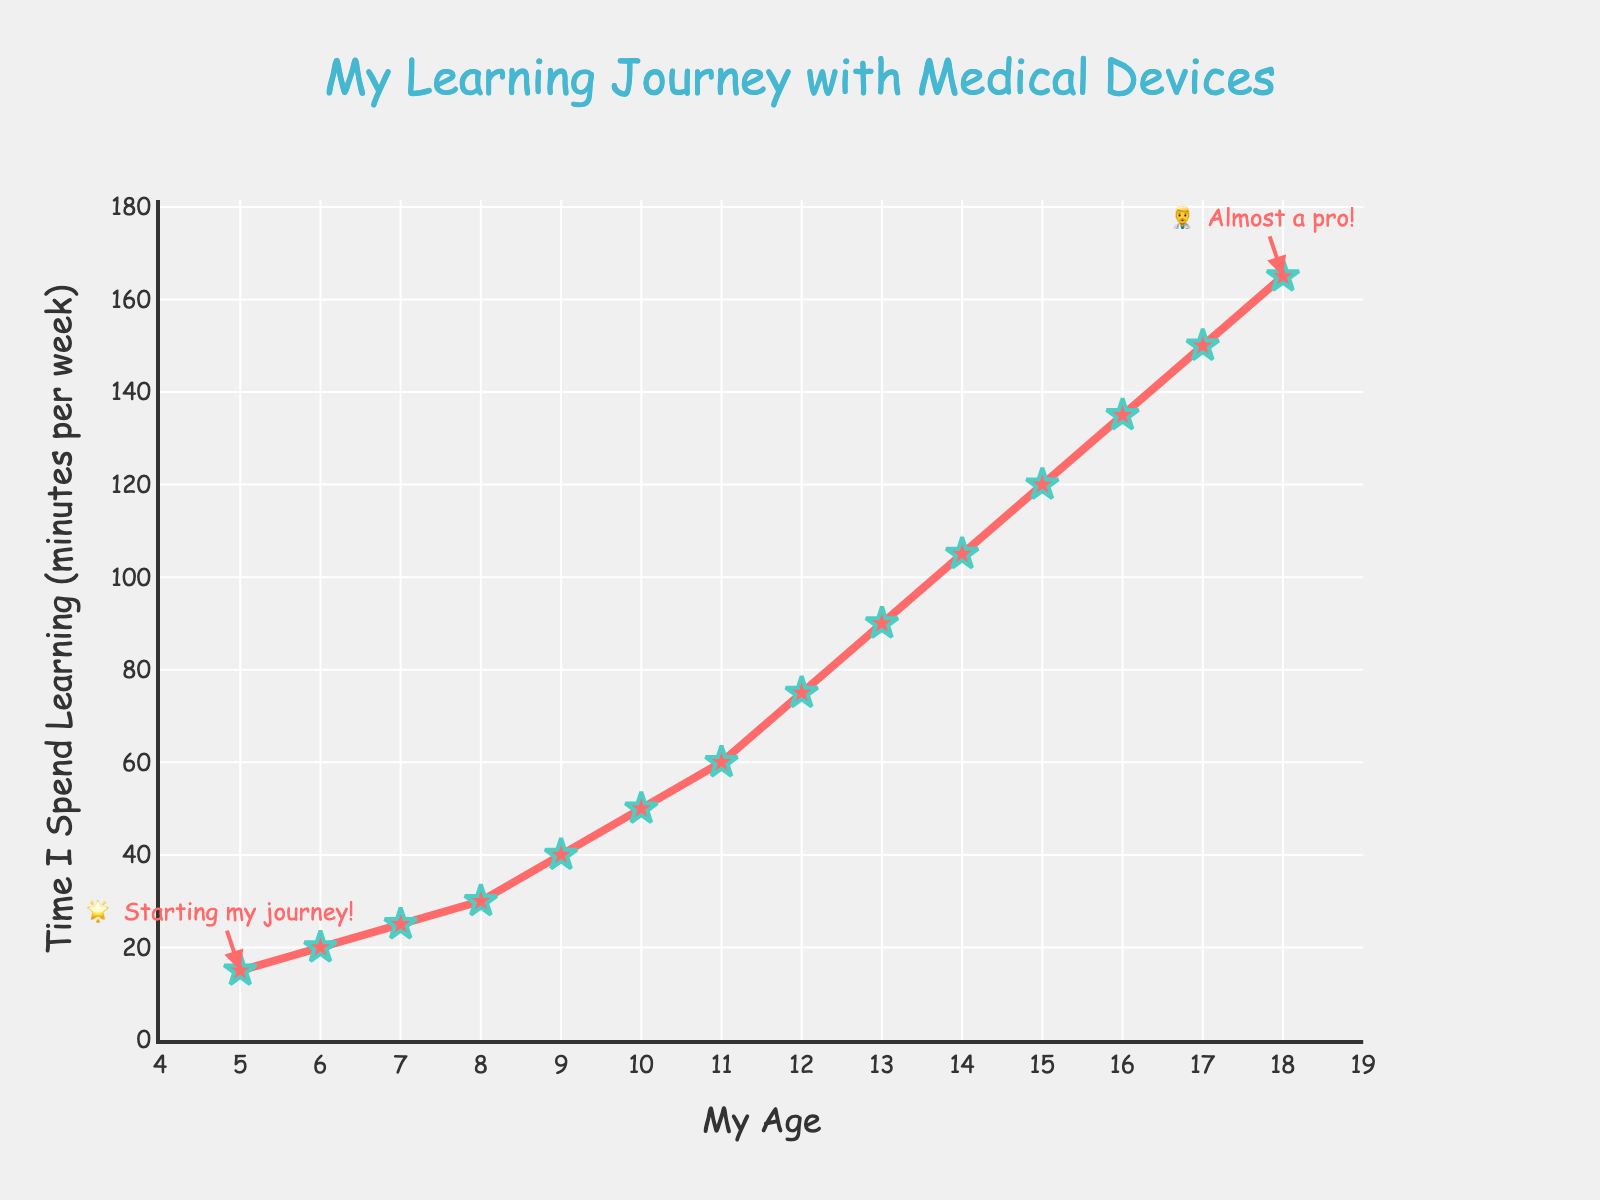What's the total time spent learning from age 5 to age 7? You need to sum the average time spent learning at ages 5, 6, and 7. The values are 15, 20, and 25 minutes per week, respectively. So, total = 15 + 20 + 25 = 60
Answer: 60 How much more time do children spend learning at age 12 compared to age 10? Subtract the average time at age 10 (50 minutes) from the average time at age 12 (75 minutes). Difference = 75 - 50 = 25
Answer: 25 Which age spends the most time learning about their medical devices? The highest point on the chart represents the age with the most time spent. At age 18, the time spent is 165 minutes per week.
Answer: 18 What is the average time spent learning from age 15 to 17? Sum the values for ages 15 (120 minutes), 16 (135 minutes), and 17 (150 minutes), and then divide by 3. So, average = (120 + 135 + 150) / 3 = 135
Answer: 135 How does the time spent learning change from ages 13 to 14 compared to ages 14 to 15? Calculate the difference between 14 and 13, and 15 and 14. Age 13 to 14: 105 - 90 = 15; Age 14 to 15: 120 - 105 = 15. The changes are the same.
Answer: Same Is the increase in learning time from age 11 to 12 greater than the increase from age 17 to 18? Calculate the increase for both intervals. Age 11 to 12: 75 - 60 = 15; Age 17 to 18: 165 - 150 = 15. Both increases are the same.
Answer: Same What is the slope of the line between ages 9 and 10? The formula for slope is (change in y) / (change in x). Between ages 9 and 10, it’s (50 - 40) / (10 - 9) = 10 / 1 = 10.
Answer: 10 What’s the median time spent learning for the ages shown? List the times: 15, 20, 25, 30, 40, 50, 60, 75, 90, 105, 120, 135, 150, 165. The median is the middle value, 67.5 minutes, between 75 and 90.
Answer: 82.5 